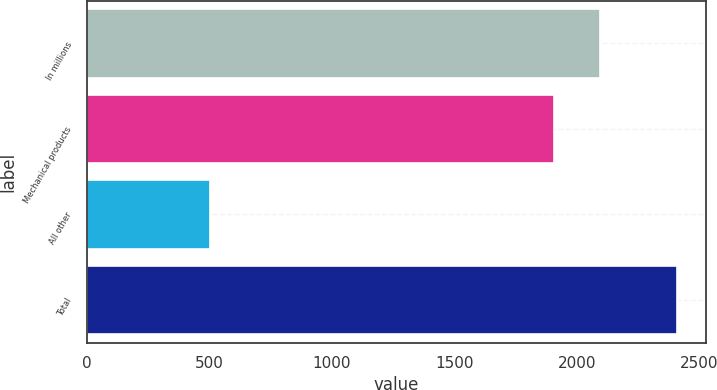Convert chart. <chart><loc_0><loc_0><loc_500><loc_500><bar_chart><fcel>In millions<fcel>Mechanical products<fcel>All other<fcel>Total<nl><fcel>2097.04<fcel>1906.4<fcel>501.8<fcel>2408.2<nl></chart> 